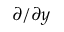<formula> <loc_0><loc_0><loc_500><loc_500>\partial / \partial y</formula> 